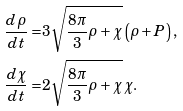Convert formula to latex. <formula><loc_0><loc_0><loc_500><loc_500>\frac { d \rho } { d t } = & 3 \sqrt { \frac { 8 \pi } { 3 } \rho + \chi } \left ( \rho + P \right ) , \\ \frac { d \chi } { d t } = & 2 \sqrt { \frac { 8 \pi } { 3 } \rho + \chi } \, \chi .</formula> 